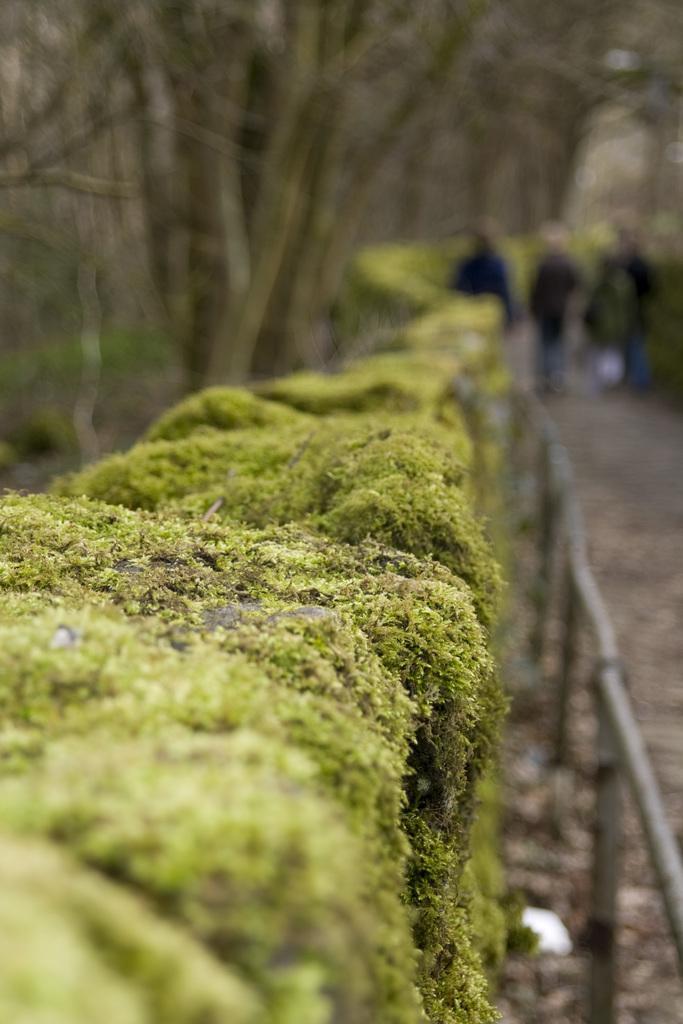Can you describe this image briefly? In this picture I can see few persons standing. I can see fence, plants, and in the background there are trees. 